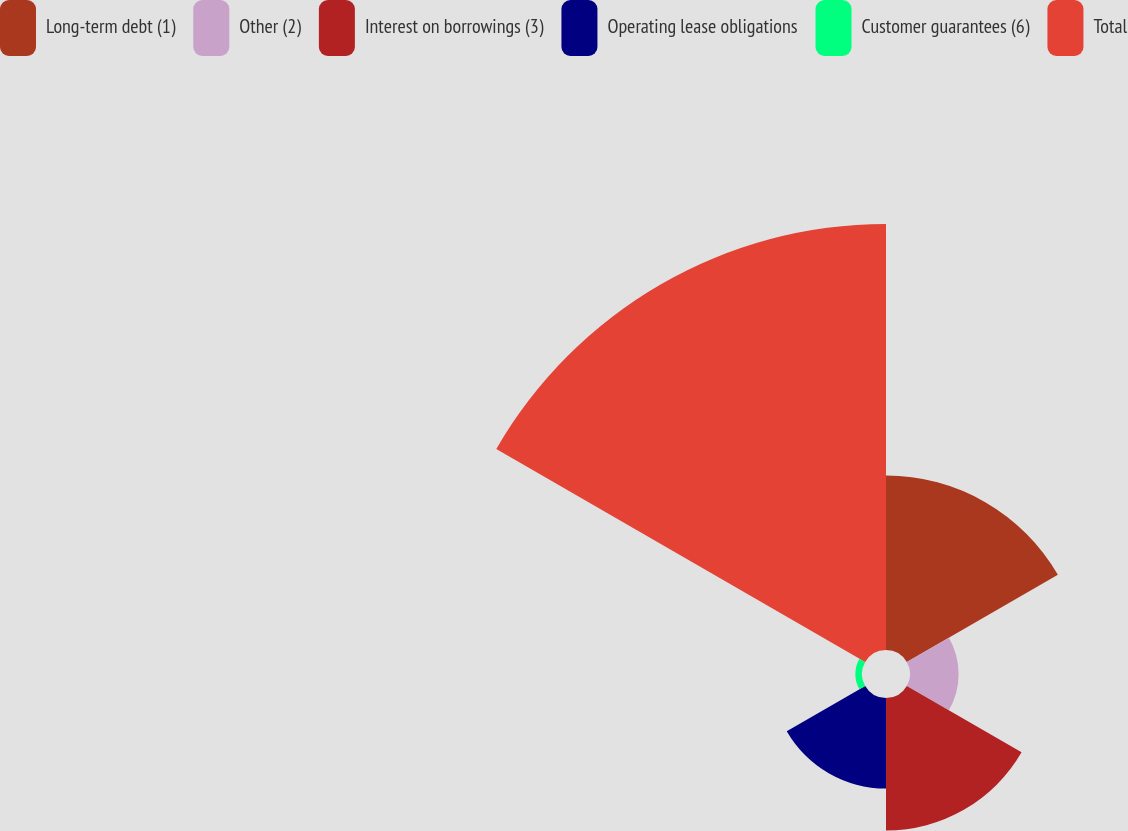Convert chart to OTSL. <chart><loc_0><loc_0><loc_500><loc_500><pie_chart><fcel>Long-term debt (1)<fcel>Other (2)<fcel>Interest on borrowings (3)<fcel>Operating lease obligations<fcel>Customer guarantees (6)<fcel>Total<nl><fcel>19.85%<fcel>5.53%<fcel>15.08%<fcel>10.31%<fcel>0.76%<fcel>48.47%<nl></chart> 